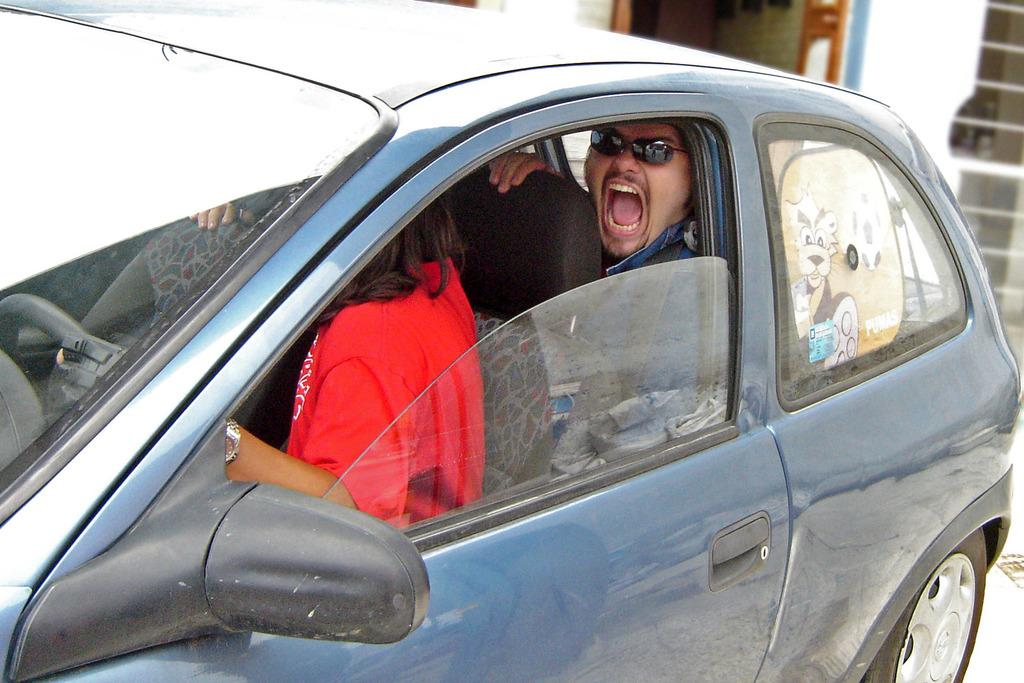What is the main subject of the image? The main subject of the image is a car. Can you describe the car in the image? The car is blue. Who is inside the car? A woman is sitting in the front seat and a man is sitting in the back seat. What is the woman wearing? The woman is wearing a red dress. What is the man doing in the image? The man is shouting and wearing goggles. What plot is being discussed by the people in the car? There is no indication in the image that the people in the car are discussing a plot, as the focus is on their attire and actions. --- Facts: 1. There is a group of people in the image. 2. The people are wearing hats. 3. The hats are red. 4. The people are holding hands. 5. The background of the image is a park. Absurd Topics: parrot, bicycle, ocean Conversation: What is the main subject of the image? The main subject of the image is a group of people. What are the people wearing in the image? The people are wearing red hats. What are the people doing in the image? The people are holding hands. What can be seen in the background of the image? The background of the image is a park. Reasoning: Let's think step by step in order to produce the conversation. We start by identifying the main subject of the image, which is the group of people. Next, we describe the people's attire, focusing on the red hats. Then, we describe the people's actions, noting that they are holding hands. Finally, we describe the background of the image, which is a park. Each question is designed to elicit a specific detail about the image that is known from the provided facts. Absurd Question/Answer: Can you see a parrot flying over the group of people in the image? There is no parrot present in the image. --- Facts: 1. There is a dog in the image. 2. The dog is brown. 3. The dog is sitting on a chair. 4. There is a book on the chair. 5. The book is open. Absurd Topics: piano, rainbow, dinosaur Conversation: What is the main subject of the image? The main subject of the image is a dog. Can you describe the dog in the image? The dog is brown and is sitting on a chair. What else can be seen on the chair? There is a book on the chair. What is the book doing in the image? The book is open. Reasoning: Let's think step by step in order to produce the conversation. We start by identifying the 